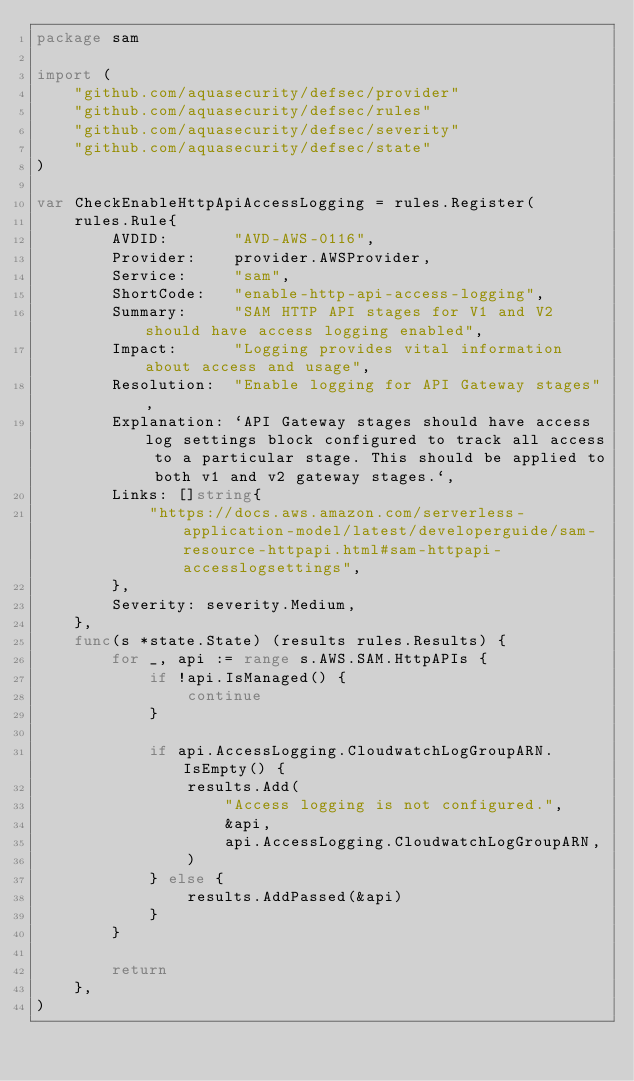Convert code to text. <code><loc_0><loc_0><loc_500><loc_500><_Go_>package sam

import (
	"github.com/aquasecurity/defsec/provider"
	"github.com/aquasecurity/defsec/rules"
	"github.com/aquasecurity/defsec/severity"
	"github.com/aquasecurity/defsec/state"
)

var CheckEnableHttpApiAccessLogging = rules.Register(
	rules.Rule{
		AVDID:       "AVD-AWS-0116",
		Provider:    provider.AWSProvider,
		Service:     "sam",
		ShortCode:   "enable-http-api-access-logging",
		Summary:     "SAM HTTP API stages for V1 and V2 should have access logging enabled",
		Impact:      "Logging provides vital information about access and usage",
		Resolution:  "Enable logging for API Gateway stages",
		Explanation: `API Gateway stages should have access log settings block configured to track all access to a particular stage. This should be applied to both v1 and v2 gateway stages.`,
		Links: []string{
			"https://docs.aws.amazon.com/serverless-application-model/latest/developerguide/sam-resource-httpapi.html#sam-httpapi-accesslogsettings",
		},
		Severity: severity.Medium,
	},
	func(s *state.State) (results rules.Results) {
		for _, api := range s.AWS.SAM.HttpAPIs {
			if !api.IsManaged() {
				continue
			}

			if api.AccessLogging.CloudwatchLogGroupARN.IsEmpty() {
				results.Add(
					"Access logging is not configured.",
					&api,
					api.AccessLogging.CloudwatchLogGroupARN,
				)
			} else {
				results.AddPassed(&api)
			}
		}

		return
	},
)
</code> 